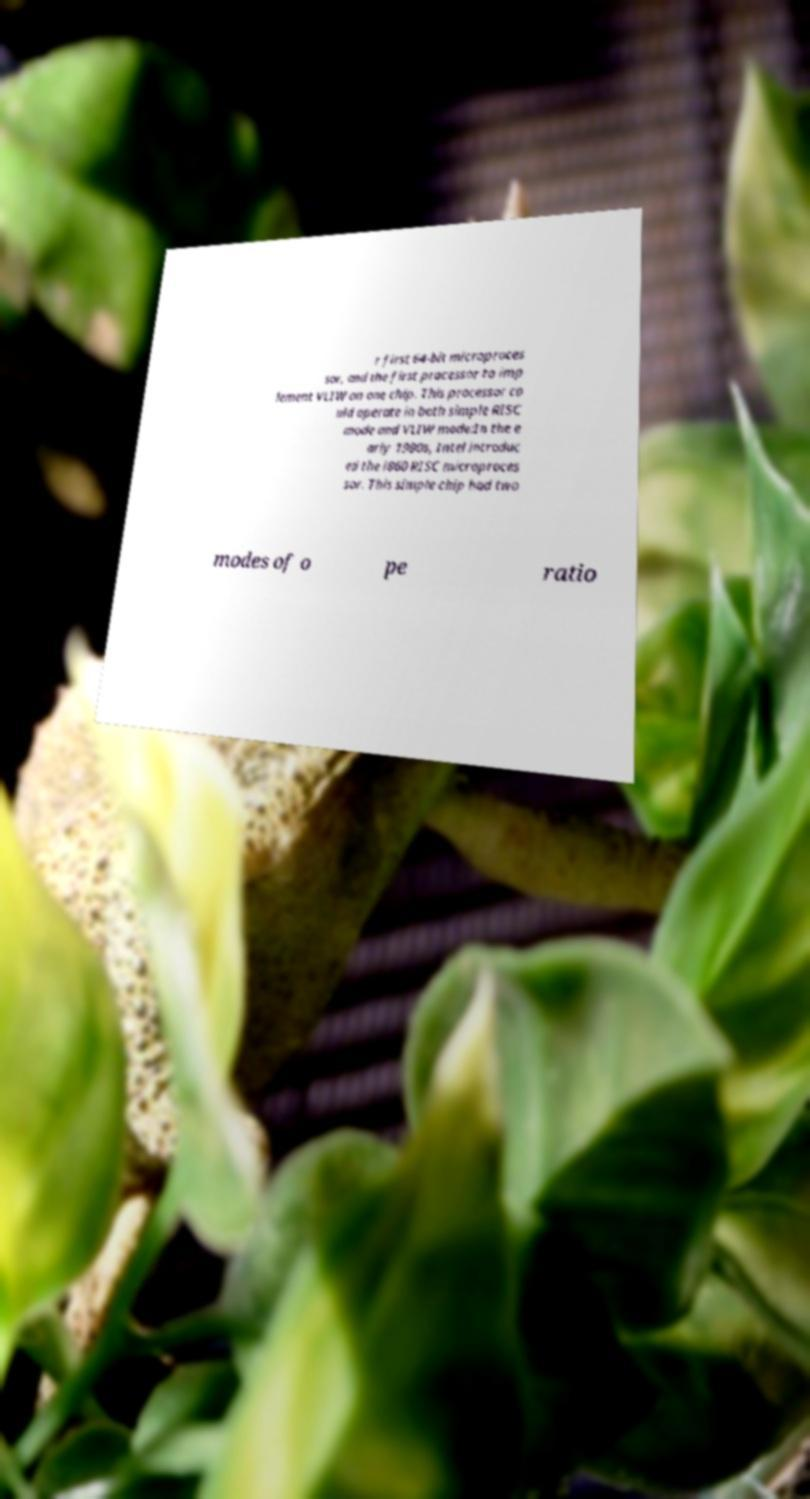Could you extract and type out the text from this image? r first 64-bit microproces sor, and the first processor to imp lement VLIW on one chip. This processor co uld operate in both simple RISC mode and VLIW mode:In the e arly 1990s, Intel introduc ed the i860 RISC microproces sor. This simple chip had two modes of o pe ratio 